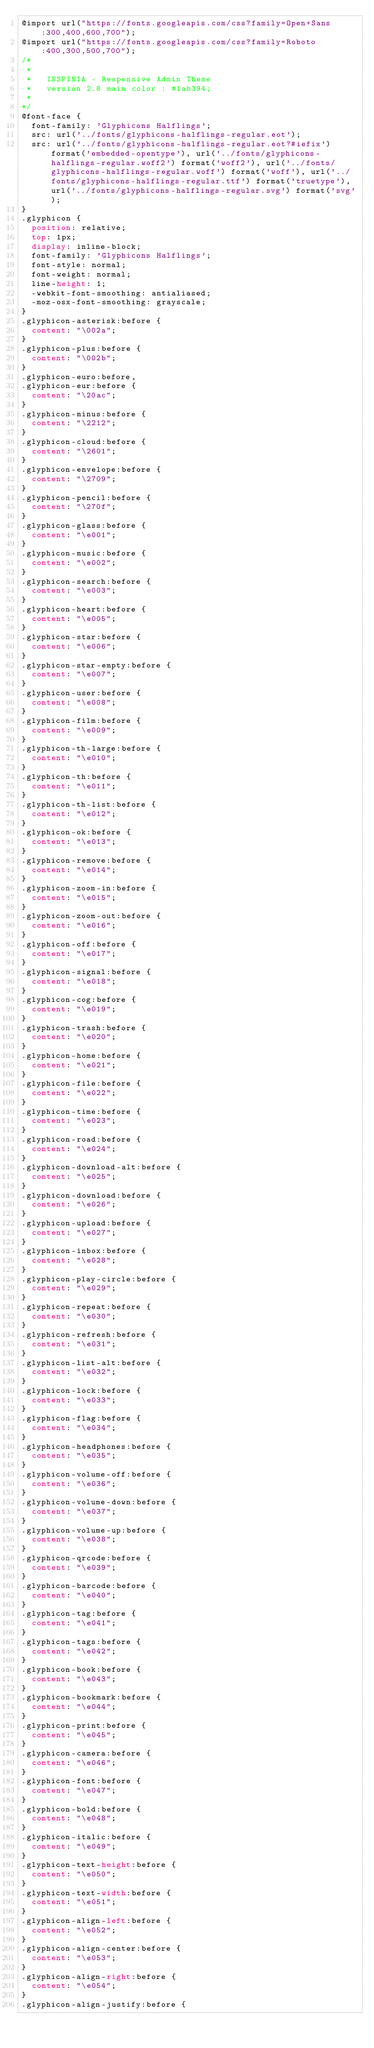<code> <loc_0><loc_0><loc_500><loc_500><_CSS_>@import url("https://fonts.googleapis.com/css?family=Open+Sans:300,400,600,700");
@import url("https://fonts.googleapis.com/css?family=Roboto:400,300,500,700");
/*
 *
 *   INSPINIA - Responsive Admin Theme
 *   version 2.8 main color : #1ab394;
 *
*/
@font-face {
  font-family: 'Glyphicons Halflings';
  src: url('../fonts/glyphicons-halflings-regular.eot');
  src: url('../fonts/glyphicons-halflings-regular.eot?#iefix') format('embedded-opentype'), url('../fonts/glyphicons-halflings-regular.woff2') format('woff2'), url('../fonts/glyphicons-halflings-regular.woff') format('woff'), url('../fonts/glyphicons-halflings-regular.ttf') format('truetype'), url('../fonts/glyphicons-halflings-regular.svg') format('svg');
}
.glyphicon {
  position: relative;
  top: 1px;
  display: inline-block;
  font-family: 'Glyphicons Halflings';
  font-style: normal;
  font-weight: normal;
  line-height: 1;
  -webkit-font-smoothing: antialiased;
  -moz-osx-font-smoothing: grayscale;
}
.glyphicon-asterisk:before {
  content: "\002a";
}
.glyphicon-plus:before {
  content: "\002b";
}
.glyphicon-euro:before,
.glyphicon-eur:before {
  content: "\20ac";
}
.glyphicon-minus:before {
  content: "\2212";
}
.glyphicon-cloud:before {
  content: "\2601";
}
.glyphicon-envelope:before {
  content: "\2709";
}
.glyphicon-pencil:before {
  content: "\270f";
}
.glyphicon-glass:before {
  content: "\e001";
}
.glyphicon-music:before {
  content: "\e002";
}
.glyphicon-search:before {
  content: "\e003";
}
.glyphicon-heart:before {
  content: "\e005";
}
.glyphicon-star:before {
  content: "\e006";
}
.glyphicon-star-empty:before {
  content: "\e007";
}
.glyphicon-user:before {
  content: "\e008";
}
.glyphicon-film:before {
  content: "\e009";
}
.glyphicon-th-large:before {
  content: "\e010";
}
.glyphicon-th:before {
  content: "\e011";
}
.glyphicon-th-list:before {
  content: "\e012";
}
.glyphicon-ok:before {
  content: "\e013";
}
.glyphicon-remove:before {
  content: "\e014";
}
.glyphicon-zoom-in:before {
  content: "\e015";
}
.glyphicon-zoom-out:before {
  content: "\e016";
}
.glyphicon-off:before {
  content: "\e017";
}
.glyphicon-signal:before {
  content: "\e018";
}
.glyphicon-cog:before {
  content: "\e019";
}
.glyphicon-trash:before {
  content: "\e020";
}
.glyphicon-home:before {
  content: "\e021";
}
.glyphicon-file:before {
  content: "\e022";
}
.glyphicon-time:before {
  content: "\e023";
}
.glyphicon-road:before {
  content: "\e024";
}
.glyphicon-download-alt:before {
  content: "\e025";
}
.glyphicon-download:before {
  content: "\e026";
}
.glyphicon-upload:before {
  content: "\e027";
}
.glyphicon-inbox:before {
  content: "\e028";
}
.glyphicon-play-circle:before {
  content: "\e029";
}
.glyphicon-repeat:before {
  content: "\e030";
}
.glyphicon-refresh:before {
  content: "\e031";
}
.glyphicon-list-alt:before {
  content: "\e032";
}
.glyphicon-lock:before {
  content: "\e033";
}
.glyphicon-flag:before {
  content: "\e034";
}
.glyphicon-headphones:before {
  content: "\e035";
}
.glyphicon-volume-off:before {
  content: "\e036";
}
.glyphicon-volume-down:before {
  content: "\e037";
}
.glyphicon-volume-up:before {
  content: "\e038";
}
.glyphicon-qrcode:before {
  content: "\e039";
}
.glyphicon-barcode:before {
  content: "\e040";
}
.glyphicon-tag:before {
  content: "\e041";
}
.glyphicon-tags:before {
  content: "\e042";
}
.glyphicon-book:before {
  content: "\e043";
}
.glyphicon-bookmark:before {
  content: "\e044";
}
.glyphicon-print:before {
  content: "\e045";
}
.glyphicon-camera:before {
  content: "\e046";
}
.glyphicon-font:before {
  content: "\e047";
}
.glyphicon-bold:before {
  content: "\e048";
}
.glyphicon-italic:before {
  content: "\e049";
}
.glyphicon-text-height:before {
  content: "\e050";
}
.glyphicon-text-width:before {
  content: "\e051";
}
.glyphicon-align-left:before {
  content: "\e052";
}
.glyphicon-align-center:before {
  content: "\e053";
}
.glyphicon-align-right:before {
  content: "\e054";
}
.glyphicon-align-justify:before {</code> 